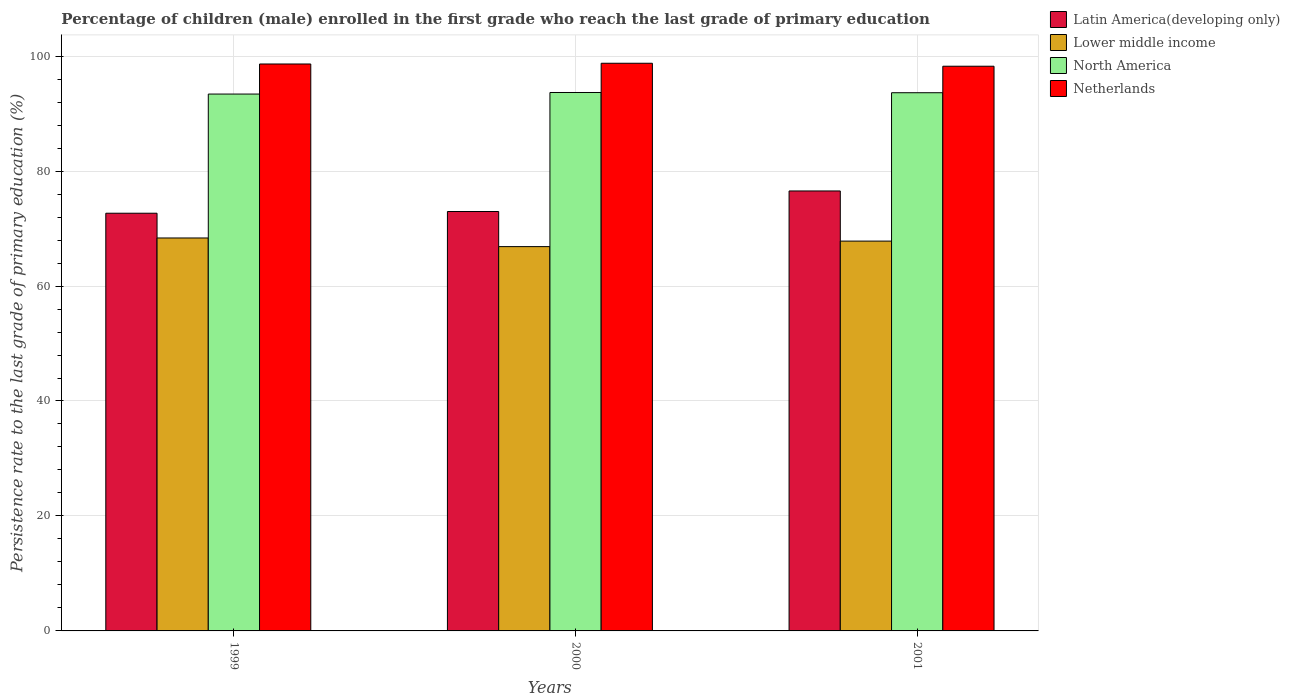How many different coloured bars are there?
Keep it short and to the point. 4. How many groups of bars are there?
Offer a very short reply. 3. Are the number of bars per tick equal to the number of legend labels?
Give a very brief answer. Yes. Are the number of bars on each tick of the X-axis equal?
Make the answer very short. Yes. What is the label of the 3rd group of bars from the left?
Offer a terse response. 2001. In how many cases, is the number of bars for a given year not equal to the number of legend labels?
Your answer should be compact. 0. What is the persistence rate of children in Lower middle income in 2001?
Provide a short and direct response. 67.82. Across all years, what is the maximum persistence rate of children in North America?
Ensure brevity in your answer.  93.67. Across all years, what is the minimum persistence rate of children in Latin America(developing only)?
Your answer should be compact. 72.67. In which year was the persistence rate of children in North America minimum?
Make the answer very short. 1999. What is the total persistence rate of children in Netherlands in the graph?
Ensure brevity in your answer.  295.62. What is the difference between the persistence rate of children in Latin America(developing only) in 1999 and that in 2000?
Keep it short and to the point. -0.3. What is the difference between the persistence rate of children in Lower middle income in 2000 and the persistence rate of children in North America in 2001?
Provide a short and direct response. -26.77. What is the average persistence rate of children in North America per year?
Offer a terse response. 93.56. In the year 2000, what is the difference between the persistence rate of children in Netherlands and persistence rate of children in North America?
Give a very brief answer. 5.09. What is the ratio of the persistence rate of children in Netherlands in 1999 to that in 2001?
Offer a very short reply. 1. What is the difference between the highest and the second highest persistence rate of children in Latin America(developing only)?
Your answer should be compact. 3.58. What is the difference between the highest and the lowest persistence rate of children in Latin America(developing only)?
Provide a short and direct response. 3.87. Is it the case that in every year, the sum of the persistence rate of children in Lower middle income and persistence rate of children in Latin America(developing only) is greater than the sum of persistence rate of children in North America and persistence rate of children in Netherlands?
Your answer should be very brief. No. What does the 1st bar from the left in 1999 represents?
Make the answer very short. Latin America(developing only). Is it the case that in every year, the sum of the persistence rate of children in Latin America(developing only) and persistence rate of children in Lower middle income is greater than the persistence rate of children in North America?
Make the answer very short. Yes. Are all the bars in the graph horizontal?
Keep it short and to the point. No. What is the difference between two consecutive major ticks on the Y-axis?
Ensure brevity in your answer.  20. Are the values on the major ticks of Y-axis written in scientific E-notation?
Provide a succinct answer. No. Does the graph contain any zero values?
Keep it short and to the point. No. Does the graph contain grids?
Your answer should be very brief. Yes. How are the legend labels stacked?
Your answer should be compact. Vertical. What is the title of the graph?
Your answer should be very brief. Percentage of children (male) enrolled in the first grade who reach the last grade of primary education. Does "El Salvador" appear as one of the legend labels in the graph?
Offer a very short reply. No. What is the label or title of the Y-axis?
Provide a succinct answer. Persistence rate to the last grade of primary education (%). What is the Persistence rate to the last grade of primary education (%) in Latin America(developing only) in 1999?
Provide a succinct answer. 72.67. What is the Persistence rate to the last grade of primary education (%) in Lower middle income in 1999?
Your answer should be very brief. 68.36. What is the Persistence rate to the last grade of primary education (%) of North America in 1999?
Offer a very short reply. 93.4. What is the Persistence rate to the last grade of primary education (%) in Netherlands in 1999?
Make the answer very short. 98.63. What is the Persistence rate to the last grade of primary education (%) in Latin America(developing only) in 2000?
Provide a succinct answer. 72.96. What is the Persistence rate to the last grade of primary education (%) of Lower middle income in 2000?
Ensure brevity in your answer.  66.86. What is the Persistence rate to the last grade of primary education (%) of North America in 2000?
Give a very brief answer. 93.67. What is the Persistence rate to the last grade of primary education (%) in Netherlands in 2000?
Ensure brevity in your answer.  98.75. What is the Persistence rate to the last grade of primary education (%) in Latin America(developing only) in 2001?
Keep it short and to the point. 76.54. What is the Persistence rate to the last grade of primary education (%) of Lower middle income in 2001?
Your answer should be very brief. 67.82. What is the Persistence rate to the last grade of primary education (%) of North America in 2001?
Keep it short and to the point. 93.63. What is the Persistence rate to the last grade of primary education (%) in Netherlands in 2001?
Ensure brevity in your answer.  98.24. Across all years, what is the maximum Persistence rate to the last grade of primary education (%) in Latin America(developing only)?
Make the answer very short. 76.54. Across all years, what is the maximum Persistence rate to the last grade of primary education (%) in Lower middle income?
Make the answer very short. 68.36. Across all years, what is the maximum Persistence rate to the last grade of primary education (%) of North America?
Make the answer very short. 93.67. Across all years, what is the maximum Persistence rate to the last grade of primary education (%) of Netherlands?
Your answer should be very brief. 98.75. Across all years, what is the minimum Persistence rate to the last grade of primary education (%) in Latin America(developing only)?
Ensure brevity in your answer.  72.67. Across all years, what is the minimum Persistence rate to the last grade of primary education (%) of Lower middle income?
Keep it short and to the point. 66.86. Across all years, what is the minimum Persistence rate to the last grade of primary education (%) of North America?
Offer a very short reply. 93.4. Across all years, what is the minimum Persistence rate to the last grade of primary education (%) of Netherlands?
Provide a succinct answer. 98.24. What is the total Persistence rate to the last grade of primary education (%) of Latin America(developing only) in the graph?
Offer a terse response. 222.17. What is the total Persistence rate to the last grade of primary education (%) of Lower middle income in the graph?
Ensure brevity in your answer.  203.03. What is the total Persistence rate to the last grade of primary education (%) of North America in the graph?
Offer a very short reply. 280.69. What is the total Persistence rate to the last grade of primary education (%) of Netherlands in the graph?
Make the answer very short. 295.62. What is the difference between the Persistence rate to the last grade of primary education (%) in Latin America(developing only) in 1999 and that in 2000?
Provide a short and direct response. -0.3. What is the difference between the Persistence rate to the last grade of primary education (%) in Lower middle income in 1999 and that in 2000?
Give a very brief answer. 1.5. What is the difference between the Persistence rate to the last grade of primary education (%) of North America in 1999 and that in 2000?
Your response must be concise. -0.27. What is the difference between the Persistence rate to the last grade of primary education (%) in Netherlands in 1999 and that in 2000?
Offer a terse response. -0.13. What is the difference between the Persistence rate to the last grade of primary education (%) of Latin America(developing only) in 1999 and that in 2001?
Make the answer very short. -3.87. What is the difference between the Persistence rate to the last grade of primary education (%) of Lower middle income in 1999 and that in 2001?
Your answer should be very brief. 0.54. What is the difference between the Persistence rate to the last grade of primary education (%) in North America in 1999 and that in 2001?
Ensure brevity in your answer.  -0.23. What is the difference between the Persistence rate to the last grade of primary education (%) in Netherlands in 1999 and that in 2001?
Your answer should be very brief. 0.39. What is the difference between the Persistence rate to the last grade of primary education (%) in Latin America(developing only) in 2000 and that in 2001?
Ensure brevity in your answer.  -3.58. What is the difference between the Persistence rate to the last grade of primary education (%) in Lower middle income in 2000 and that in 2001?
Give a very brief answer. -0.96. What is the difference between the Persistence rate to the last grade of primary education (%) of North America in 2000 and that in 2001?
Provide a succinct answer. 0.04. What is the difference between the Persistence rate to the last grade of primary education (%) in Netherlands in 2000 and that in 2001?
Make the answer very short. 0.52. What is the difference between the Persistence rate to the last grade of primary education (%) of Latin America(developing only) in 1999 and the Persistence rate to the last grade of primary education (%) of Lower middle income in 2000?
Offer a very short reply. 5.81. What is the difference between the Persistence rate to the last grade of primary education (%) in Latin America(developing only) in 1999 and the Persistence rate to the last grade of primary education (%) in North America in 2000?
Make the answer very short. -21. What is the difference between the Persistence rate to the last grade of primary education (%) of Latin America(developing only) in 1999 and the Persistence rate to the last grade of primary education (%) of Netherlands in 2000?
Offer a very short reply. -26.09. What is the difference between the Persistence rate to the last grade of primary education (%) in Lower middle income in 1999 and the Persistence rate to the last grade of primary education (%) in North America in 2000?
Provide a short and direct response. -25.31. What is the difference between the Persistence rate to the last grade of primary education (%) of Lower middle income in 1999 and the Persistence rate to the last grade of primary education (%) of Netherlands in 2000?
Give a very brief answer. -30.4. What is the difference between the Persistence rate to the last grade of primary education (%) in North America in 1999 and the Persistence rate to the last grade of primary education (%) in Netherlands in 2000?
Make the answer very short. -5.36. What is the difference between the Persistence rate to the last grade of primary education (%) of Latin America(developing only) in 1999 and the Persistence rate to the last grade of primary education (%) of Lower middle income in 2001?
Offer a terse response. 4.85. What is the difference between the Persistence rate to the last grade of primary education (%) in Latin America(developing only) in 1999 and the Persistence rate to the last grade of primary education (%) in North America in 2001?
Your response must be concise. -20.96. What is the difference between the Persistence rate to the last grade of primary education (%) of Latin America(developing only) in 1999 and the Persistence rate to the last grade of primary education (%) of Netherlands in 2001?
Your answer should be very brief. -25.57. What is the difference between the Persistence rate to the last grade of primary education (%) of Lower middle income in 1999 and the Persistence rate to the last grade of primary education (%) of North America in 2001?
Your response must be concise. -25.27. What is the difference between the Persistence rate to the last grade of primary education (%) of Lower middle income in 1999 and the Persistence rate to the last grade of primary education (%) of Netherlands in 2001?
Your answer should be very brief. -29.88. What is the difference between the Persistence rate to the last grade of primary education (%) of North America in 1999 and the Persistence rate to the last grade of primary education (%) of Netherlands in 2001?
Your response must be concise. -4.84. What is the difference between the Persistence rate to the last grade of primary education (%) of Latin America(developing only) in 2000 and the Persistence rate to the last grade of primary education (%) of Lower middle income in 2001?
Offer a very short reply. 5.15. What is the difference between the Persistence rate to the last grade of primary education (%) of Latin America(developing only) in 2000 and the Persistence rate to the last grade of primary education (%) of North America in 2001?
Your answer should be very brief. -20.66. What is the difference between the Persistence rate to the last grade of primary education (%) in Latin America(developing only) in 2000 and the Persistence rate to the last grade of primary education (%) in Netherlands in 2001?
Keep it short and to the point. -25.28. What is the difference between the Persistence rate to the last grade of primary education (%) of Lower middle income in 2000 and the Persistence rate to the last grade of primary education (%) of North America in 2001?
Your response must be concise. -26.77. What is the difference between the Persistence rate to the last grade of primary education (%) in Lower middle income in 2000 and the Persistence rate to the last grade of primary education (%) in Netherlands in 2001?
Offer a very short reply. -31.38. What is the difference between the Persistence rate to the last grade of primary education (%) in North America in 2000 and the Persistence rate to the last grade of primary education (%) in Netherlands in 2001?
Offer a very short reply. -4.57. What is the average Persistence rate to the last grade of primary education (%) of Latin America(developing only) per year?
Give a very brief answer. 74.06. What is the average Persistence rate to the last grade of primary education (%) of Lower middle income per year?
Ensure brevity in your answer.  67.68. What is the average Persistence rate to the last grade of primary education (%) of North America per year?
Your answer should be compact. 93.56. What is the average Persistence rate to the last grade of primary education (%) of Netherlands per year?
Your answer should be compact. 98.54. In the year 1999, what is the difference between the Persistence rate to the last grade of primary education (%) in Latin America(developing only) and Persistence rate to the last grade of primary education (%) in Lower middle income?
Your response must be concise. 4.31. In the year 1999, what is the difference between the Persistence rate to the last grade of primary education (%) in Latin America(developing only) and Persistence rate to the last grade of primary education (%) in North America?
Your answer should be compact. -20.73. In the year 1999, what is the difference between the Persistence rate to the last grade of primary education (%) in Latin America(developing only) and Persistence rate to the last grade of primary education (%) in Netherlands?
Your response must be concise. -25.96. In the year 1999, what is the difference between the Persistence rate to the last grade of primary education (%) of Lower middle income and Persistence rate to the last grade of primary education (%) of North America?
Ensure brevity in your answer.  -25.04. In the year 1999, what is the difference between the Persistence rate to the last grade of primary education (%) of Lower middle income and Persistence rate to the last grade of primary education (%) of Netherlands?
Provide a succinct answer. -30.27. In the year 1999, what is the difference between the Persistence rate to the last grade of primary education (%) of North America and Persistence rate to the last grade of primary education (%) of Netherlands?
Ensure brevity in your answer.  -5.23. In the year 2000, what is the difference between the Persistence rate to the last grade of primary education (%) of Latin America(developing only) and Persistence rate to the last grade of primary education (%) of Lower middle income?
Provide a short and direct response. 6.11. In the year 2000, what is the difference between the Persistence rate to the last grade of primary education (%) in Latin America(developing only) and Persistence rate to the last grade of primary education (%) in North America?
Offer a very short reply. -20.7. In the year 2000, what is the difference between the Persistence rate to the last grade of primary education (%) of Latin America(developing only) and Persistence rate to the last grade of primary education (%) of Netherlands?
Provide a short and direct response. -25.79. In the year 2000, what is the difference between the Persistence rate to the last grade of primary education (%) of Lower middle income and Persistence rate to the last grade of primary education (%) of North America?
Offer a very short reply. -26.81. In the year 2000, what is the difference between the Persistence rate to the last grade of primary education (%) in Lower middle income and Persistence rate to the last grade of primary education (%) in Netherlands?
Keep it short and to the point. -31.9. In the year 2000, what is the difference between the Persistence rate to the last grade of primary education (%) of North America and Persistence rate to the last grade of primary education (%) of Netherlands?
Offer a terse response. -5.09. In the year 2001, what is the difference between the Persistence rate to the last grade of primary education (%) of Latin America(developing only) and Persistence rate to the last grade of primary education (%) of Lower middle income?
Provide a succinct answer. 8.72. In the year 2001, what is the difference between the Persistence rate to the last grade of primary education (%) in Latin America(developing only) and Persistence rate to the last grade of primary education (%) in North America?
Keep it short and to the point. -17.09. In the year 2001, what is the difference between the Persistence rate to the last grade of primary education (%) of Latin America(developing only) and Persistence rate to the last grade of primary education (%) of Netherlands?
Ensure brevity in your answer.  -21.7. In the year 2001, what is the difference between the Persistence rate to the last grade of primary education (%) of Lower middle income and Persistence rate to the last grade of primary education (%) of North America?
Your answer should be very brief. -25.81. In the year 2001, what is the difference between the Persistence rate to the last grade of primary education (%) in Lower middle income and Persistence rate to the last grade of primary education (%) in Netherlands?
Your answer should be very brief. -30.42. In the year 2001, what is the difference between the Persistence rate to the last grade of primary education (%) in North America and Persistence rate to the last grade of primary education (%) in Netherlands?
Offer a very short reply. -4.61. What is the ratio of the Persistence rate to the last grade of primary education (%) of Lower middle income in 1999 to that in 2000?
Keep it short and to the point. 1.02. What is the ratio of the Persistence rate to the last grade of primary education (%) in North America in 1999 to that in 2000?
Provide a short and direct response. 1. What is the ratio of the Persistence rate to the last grade of primary education (%) in Netherlands in 1999 to that in 2000?
Keep it short and to the point. 1. What is the ratio of the Persistence rate to the last grade of primary education (%) of Latin America(developing only) in 1999 to that in 2001?
Ensure brevity in your answer.  0.95. What is the ratio of the Persistence rate to the last grade of primary education (%) in Lower middle income in 1999 to that in 2001?
Offer a very short reply. 1.01. What is the ratio of the Persistence rate to the last grade of primary education (%) in North America in 1999 to that in 2001?
Make the answer very short. 1. What is the ratio of the Persistence rate to the last grade of primary education (%) in Netherlands in 1999 to that in 2001?
Ensure brevity in your answer.  1. What is the ratio of the Persistence rate to the last grade of primary education (%) in Latin America(developing only) in 2000 to that in 2001?
Ensure brevity in your answer.  0.95. What is the ratio of the Persistence rate to the last grade of primary education (%) of Lower middle income in 2000 to that in 2001?
Keep it short and to the point. 0.99. What is the ratio of the Persistence rate to the last grade of primary education (%) of North America in 2000 to that in 2001?
Make the answer very short. 1. What is the difference between the highest and the second highest Persistence rate to the last grade of primary education (%) of Latin America(developing only)?
Provide a succinct answer. 3.58. What is the difference between the highest and the second highest Persistence rate to the last grade of primary education (%) in Lower middle income?
Your answer should be very brief. 0.54. What is the difference between the highest and the second highest Persistence rate to the last grade of primary education (%) of North America?
Offer a terse response. 0.04. What is the difference between the highest and the second highest Persistence rate to the last grade of primary education (%) of Netherlands?
Provide a succinct answer. 0.13. What is the difference between the highest and the lowest Persistence rate to the last grade of primary education (%) in Latin America(developing only)?
Offer a terse response. 3.87. What is the difference between the highest and the lowest Persistence rate to the last grade of primary education (%) of Lower middle income?
Your answer should be very brief. 1.5. What is the difference between the highest and the lowest Persistence rate to the last grade of primary education (%) in North America?
Offer a terse response. 0.27. What is the difference between the highest and the lowest Persistence rate to the last grade of primary education (%) of Netherlands?
Your answer should be very brief. 0.52. 